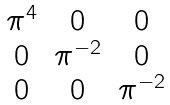Convert formula to latex. <formula><loc_0><loc_0><loc_500><loc_500>\begin{matrix} \pi ^ { 4 } & 0 & 0 \\ 0 & \pi ^ { - 2 } & 0 \\ 0 & 0 & \pi ^ { - 2 } \end{matrix}</formula> 